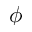<formula> <loc_0><loc_0><loc_500><loc_500>\phi</formula> 